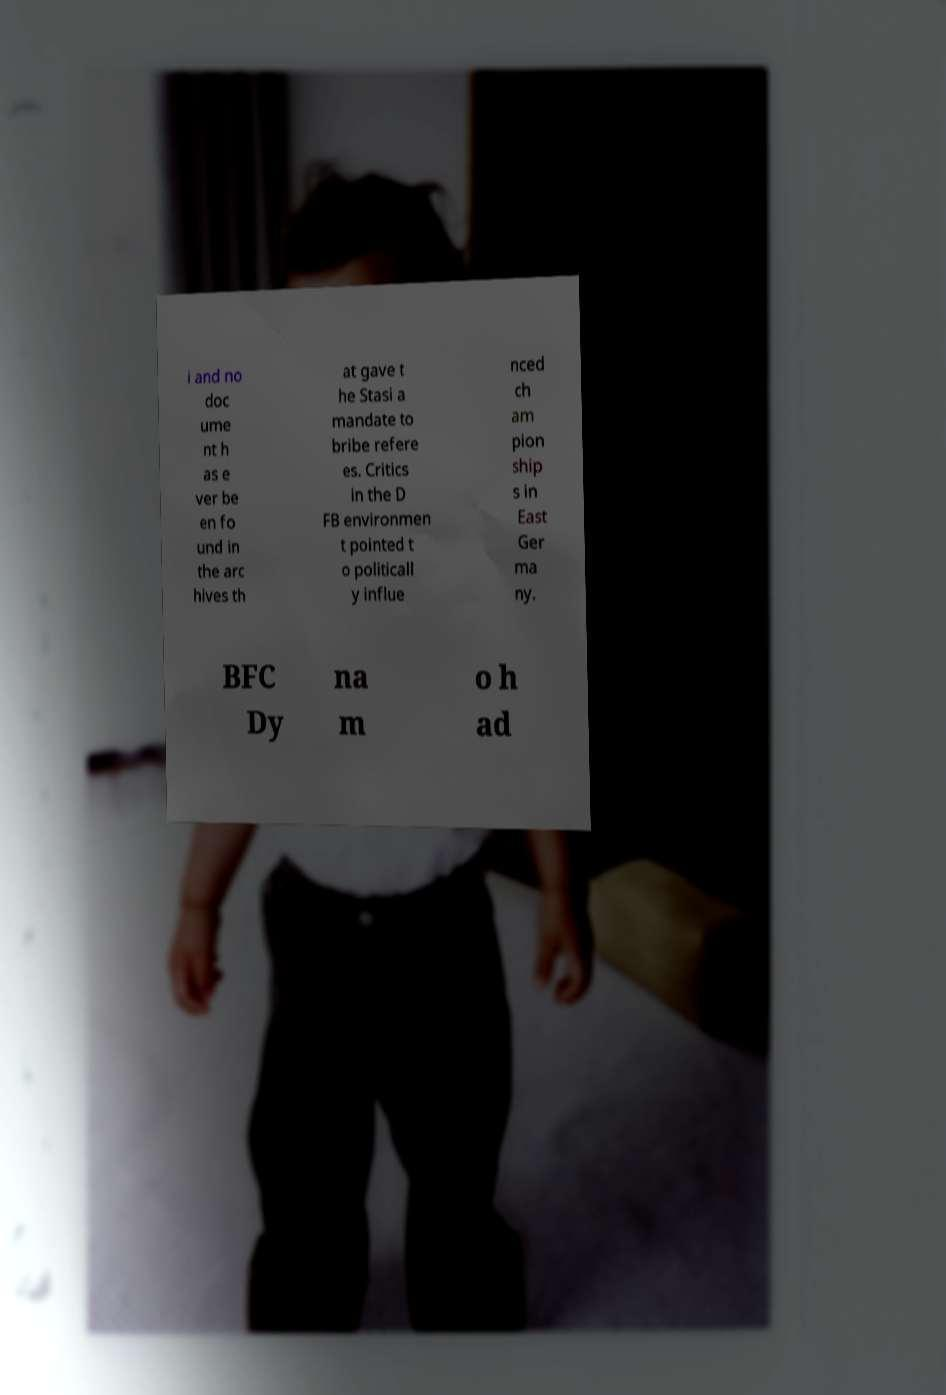I need the written content from this picture converted into text. Can you do that? i and no doc ume nt h as e ver be en fo und in the arc hives th at gave t he Stasi a mandate to bribe refere es. Critics in the D FB environmen t pointed t o politicall y influe nced ch am pion ship s in East Ger ma ny. BFC Dy na m o h ad 